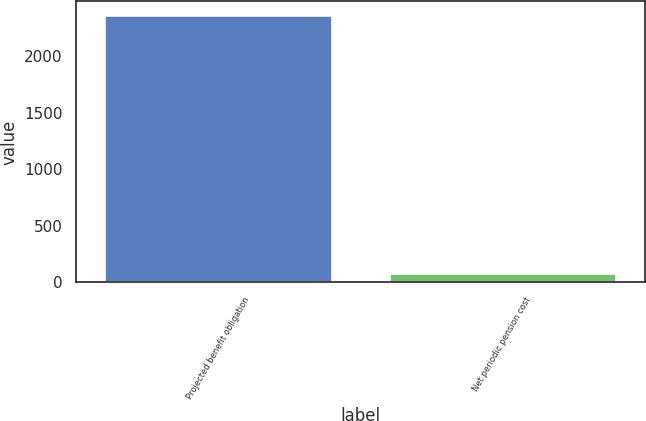Convert chart. <chart><loc_0><loc_0><loc_500><loc_500><bar_chart><fcel>Projected benefit obligation<fcel>Net periodic pension cost<nl><fcel>2364<fcel>84<nl></chart> 